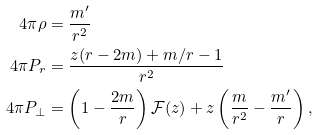<formula> <loc_0><loc_0><loc_500><loc_500>4 \pi \rho & = \frac { m ^ { \prime } } { r ^ { 2 } } \\ 4 \pi P _ { r } & = \frac { z ( r - 2 m ) + m / r - 1 } { r ^ { 2 } } \\ 4 \pi P _ { \perp } & = \left ( 1 - \frac { 2 m } { r } \right ) \mathcal { F } ( z ) + z \left ( \frac { m } { r ^ { 2 } } - \frac { m ^ { \prime } } { r } \right ) ,</formula> 